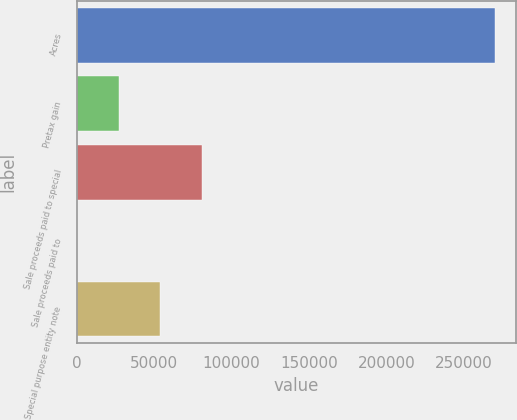<chart> <loc_0><loc_0><loc_500><loc_500><bar_chart><fcel>Acres<fcel>Pretax gain<fcel>Sale proceeds paid to special<fcel>Sale proceeds paid to<fcel>Special purpose entity note<nl><fcel>270000<fcel>27019.8<fcel>81015.4<fcel>22<fcel>54017.6<nl></chart> 